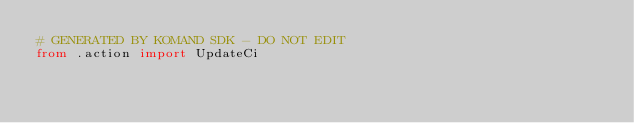Convert code to text. <code><loc_0><loc_0><loc_500><loc_500><_Python_># GENERATED BY KOMAND SDK - DO NOT EDIT
from .action import UpdateCi
</code> 